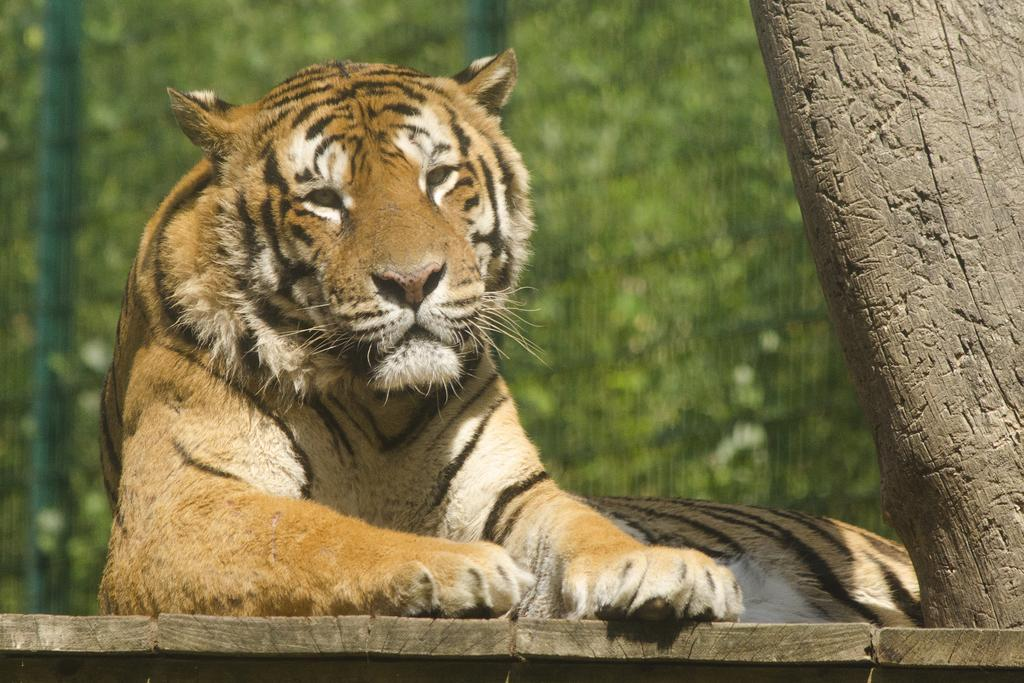What type of animal is in the image? There is a tiger in the image. What color is the background of the image? The background of the image is green. Can you describe the object on the right side of the image? Unfortunately, the facts provided do not specify the nature of the object on the right side of the image. What type of wool is the tiger using to make a tail in the image? There is no wool or tail-making activity present in the image. The tiger is a wild animal and does not use wool to create a tail. 